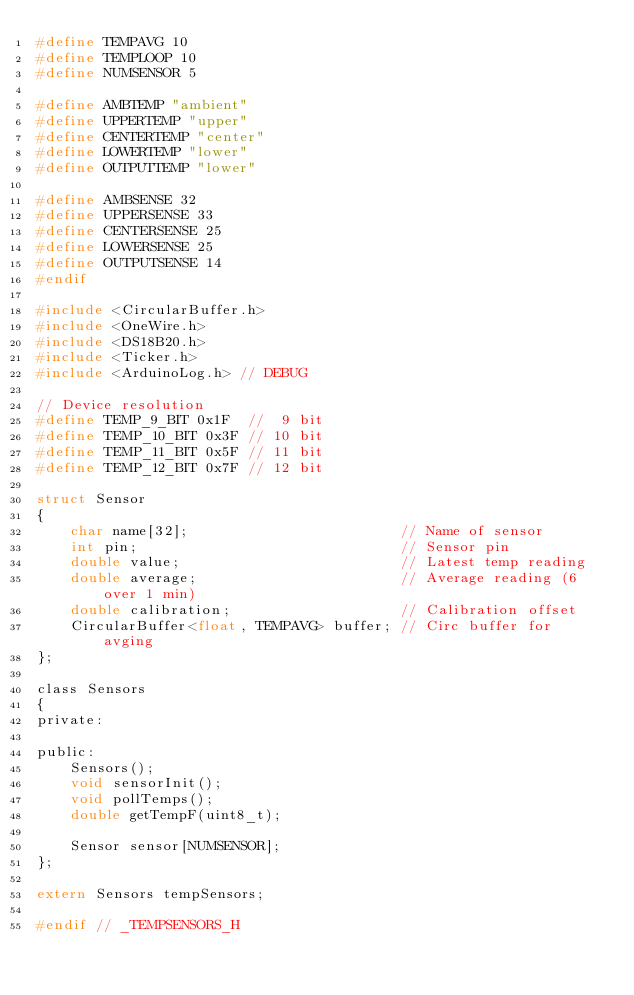<code> <loc_0><loc_0><loc_500><loc_500><_C_>#define TEMPAVG 10
#define TEMPLOOP 10
#define NUMSENSOR 5

#define AMBTEMP "ambient"
#define UPPERTEMP "upper"
#define CENTERTEMP "center"
#define LOWERTEMP "lower"
#define OUTPUTTEMP "lower"

#define AMBSENSE 32
#define UPPERSENSE 33
#define CENTERSENSE 25
#define LOWERSENSE 25
#define OUTPUTSENSE 14
#endif

#include <CircularBuffer.h>
#include <OneWire.h>
#include <DS18B20.h>
#include <Ticker.h>
#include <ArduinoLog.h> // DEBUG

// Device resolution
#define TEMP_9_BIT 0x1F  //  9 bit
#define TEMP_10_BIT 0x3F // 10 bit
#define TEMP_11_BIT 0x5F // 11 bit
#define TEMP_12_BIT 0x7F // 12 bit

struct Sensor
{
    char name[32];                         // Name of sensor
    int pin;                               // Sensor pin
    double value;                          // Latest temp reading
    double average;                        // Average reading (6 over 1 min)
    double calibration;                    // Calibration offset
    CircularBuffer<float, TEMPAVG> buffer; // Circ buffer for avging
};

class Sensors
{
private:

public:
    Sensors();
    void sensorInit();
    void pollTemps();
    double getTempF(uint8_t);

    Sensor sensor[NUMSENSOR];
};

extern Sensors tempSensors;

#endif // _TEMPSENSORS_H
</code> 